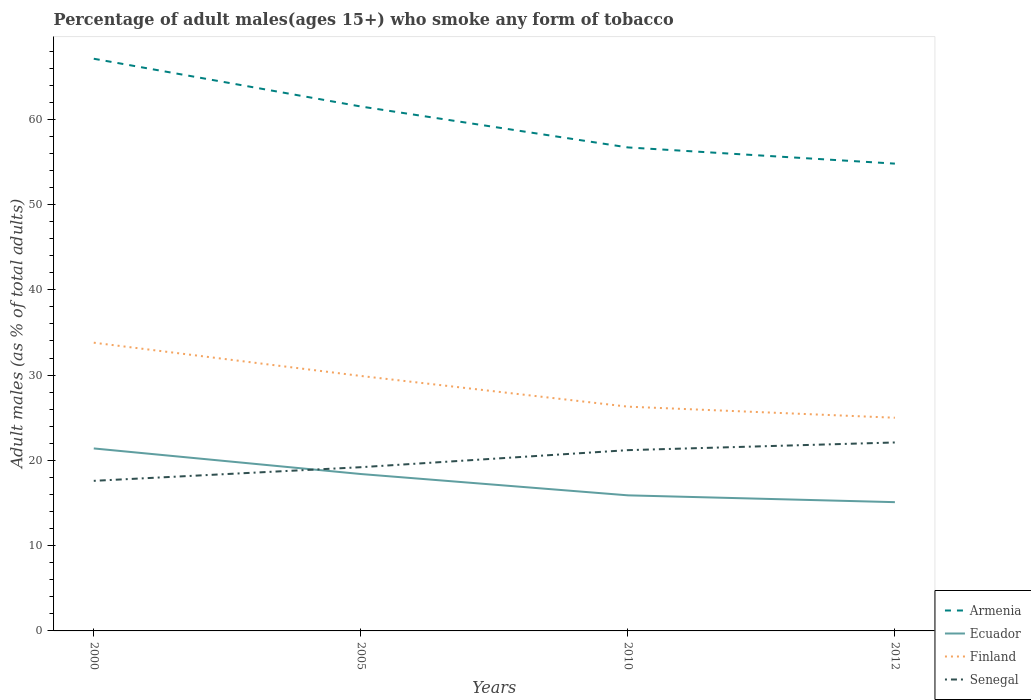How many different coloured lines are there?
Offer a very short reply. 4. Is the number of lines equal to the number of legend labels?
Provide a succinct answer. Yes. Across all years, what is the maximum percentage of adult males who smoke in Armenia?
Your answer should be compact. 54.8. In which year was the percentage of adult males who smoke in Senegal maximum?
Your answer should be compact. 2000. What is the total percentage of adult males who smoke in Finland in the graph?
Your answer should be very brief. 3.9. What is the difference between the highest and the second highest percentage of adult males who smoke in Senegal?
Keep it short and to the point. 4.5. What is the difference between the highest and the lowest percentage of adult males who smoke in Ecuador?
Give a very brief answer. 2. What is the difference between two consecutive major ticks on the Y-axis?
Provide a short and direct response. 10. Does the graph contain grids?
Make the answer very short. No. What is the title of the graph?
Your answer should be very brief. Percentage of adult males(ages 15+) who smoke any form of tobacco. Does "Yemen, Rep." appear as one of the legend labels in the graph?
Provide a short and direct response. No. What is the label or title of the Y-axis?
Offer a terse response. Adult males (as % of total adults). What is the Adult males (as % of total adults) in Armenia in 2000?
Your answer should be compact. 67.1. What is the Adult males (as % of total adults) in Ecuador in 2000?
Provide a succinct answer. 21.4. What is the Adult males (as % of total adults) of Finland in 2000?
Give a very brief answer. 33.8. What is the Adult males (as % of total adults) in Armenia in 2005?
Give a very brief answer. 61.5. What is the Adult males (as % of total adults) of Ecuador in 2005?
Your answer should be very brief. 18.4. What is the Adult males (as % of total adults) of Finland in 2005?
Offer a terse response. 29.9. What is the Adult males (as % of total adults) in Armenia in 2010?
Ensure brevity in your answer.  56.7. What is the Adult males (as % of total adults) in Finland in 2010?
Keep it short and to the point. 26.3. What is the Adult males (as % of total adults) of Senegal in 2010?
Keep it short and to the point. 21.2. What is the Adult males (as % of total adults) of Armenia in 2012?
Your response must be concise. 54.8. What is the Adult males (as % of total adults) of Ecuador in 2012?
Give a very brief answer. 15.1. What is the Adult males (as % of total adults) of Finland in 2012?
Provide a succinct answer. 25. What is the Adult males (as % of total adults) in Senegal in 2012?
Provide a succinct answer. 22.1. Across all years, what is the maximum Adult males (as % of total adults) of Armenia?
Offer a very short reply. 67.1. Across all years, what is the maximum Adult males (as % of total adults) of Ecuador?
Ensure brevity in your answer.  21.4. Across all years, what is the maximum Adult males (as % of total adults) of Finland?
Give a very brief answer. 33.8. Across all years, what is the maximum Adult males (as % of total adults) of Senegal?
Provide a short and direct response. 22.1. Across all years, what is the minimum Adult males (as % of total adults) in Armenia?
Make the answer very short. 54.8. Across all years, what is the minimum Adult males (as % of total adults) in Ecuador?
Provide a succinct answer. 15.1. Across all years, what is the minimum Adult males (as % of total adults) of Finland?
Ensure brevity in your answer.  25. What is the total Adult males (as % of total adults) of Armenia in the graph?
Provide a short and direct response. 240.1. What is the total Adult males (as % of total adults) in Ecuador in the graph?
Give a very brief answer. 70.8. What is the total Adult males (as % of total adults) of Finland in the graph?
Your answer should be very brief. 115. What is the total Adult males (as % of total adults) of Senegal in the graph?
Provide a short and direct response. 80.1. What is the difference between the Adult males (as % of total adults) in Armenia in 2000 and that in 2005?
Make the answer very short. 5.6. What is the difference between the Adult males (as % of total adults) in Ecuador in 2000 and that in 2005?
Your answer should be very brief. 3. What is the difference between the Adult males (as % of total adults) in Senegal in 2000 and that in 2005?
Keep it short and to the point. -1.6. What is the difference between the Adult males (as % of total adults) in Armenia in 2000 and that in 2010?
Offer a terse response. 10.4. What is the difference between the Adult males (as % of total adults) of Ecuador in 2000 and that in 2010?
Keep it short and to the point. 5.5. What is the difference between the Adult males (as % of total adults) of Finland in 2000 and that in 2010?
Provide a short and direct response. 7.5. What is the difference between the Adult males (as % of total adults) in Senegal in 2000 and that in 2010?
Ensure brevity in your answer.  -3.6. What is the difference between the Adult males (as % of total adults) of Armenia in 2000 and that in 2012?
Your response must be concise. 12.3. What is the difference between the Adult males (as % of total adults) of Ecuador in 2000 and that in 2012?
Offer a very short reply. 6.3. What is the difference between the Adult males (as % of total adults) in Finland in 2000 and that in 2012?
Make the answer very short. 8.8. What is the difference between the Adult males (as % of total adults) of Senegal in 2005 and that in 2010?
Provide a short and direct response. -2. What is the difference between the Adult males (as % of total adults) of Armenia in 2005 and that in 2012?
Make the answer very short. 6.7. What is the difference between the Adult males (as % of total adults) in Ecuador in 2005 and that in 2012?
Offer a very short reply. 3.3. What is the difference between the Adult males (as % of total adults) in Finland in 2005 and that in 2012?
Provide a succinct answer. 4.9. What is the difference between the Adult males (as % of total adults) in Senegal in 2010 and that in 2012?
Keep it short and to the point. -0.9. What is the difference between the Adult males (as % of total adults) in Armenia in 2000 and the Adult males (as % of total adults) in Ecuador in 2005?
Your answer should be very brief. 48.7. What is the difference between the Adult males (as % of total adults) of Armenia in 2000 and the Adult males (as % of total adults) of Finland in 2005?
Give a very brief answer. 37.2. What is the difference between the Adult males (as % of total adults) of Armenia in 2000 and the Adult males (as % of total adults) of Senegal in 2005?
Make the answer very short. 47.9. What is the difference between the Adult males (as % of total adults) of Ecuador in 2000 and the Adult males (as % of total adults) of Senegal in 2005?
Your answer should be very brief. 2.2. What is the difference between the Adult males (as % of total adults) in Armenia in 2000 and the Adult males (as % of total adults) in Ecuador in 2010?
Your answer should be compact. 51.2. What is the difference between the Adult males (as % of total adults) in Armenia in 2000 and the Adult males (as % of total adults) in Finland in 2010?
Your response must be concise. 40.8. What is the difference between the Adult males (as % of total adults) in Armenia in 2000 and the Adult males (as % of total adults) in Senegal in 2010?
Provide a succinct answer. 45.9. What is the difference between the Adult males (as % of total adults) of Ecuador in 2000 and the Adult males (as % of total adults) of Finland in 2010?
Provide a succinct answer. -4.9. What is the difference between the Adult males (as % of total adults) in Ecuador in 2000 and the Adult males (as % of total adults) in Senegal in 2010?
Your response must be concise. 0.2. What is the difference between the Adult males (as % of total adults) in Finland in 2000 and the Adult males (as % of total adults) in Senegal in 2010?
Ensure brevity in your answer.  12.6. What is the difference between the Adult males (as % of total adults) of Armenia in 2000 and the Adult males (as % of total adults) of Finland in 2012?
Offer a terse response. 42.1. What is the difference between the Adult males (as % of total adults) of Armenia in 2005 and the Adult males (as % of total adults) of Ecuador in 2010?
Ensure brevity in your answer.  45.6. What is the difference between the Adult males (as % of total adults) of Armenia in 2005 and the Adult males (as % of total adults) of Finland in 2010?
Ensure brevity in your answer.  35.2. What is the difference between the Adult males (as % of total adults) in Armenia in 2005 and the Adult males (as % of total adults) in Senegal in 2010?
Your response must be concise. 40.3. What is the difference between the Adult males (as % of total adults) in Finland in 2005 and the Adult males (as % of total adults) in Senegal in 2010?
Your answer should be compact. 8.7. What is the difference between the Adult males (as % of total adults) of Armenia in 2005 and the Adult males (as % of total adults) of Ecuador in 2012?
Ensure brevity in your answer.  46.4. What is the difference between the Adult males (as % of total adults) of Armenia in 2005 and the Adult males (as % of total adults) of Finland in 2012?
Ensure brevity in your answer.  36.5. What is the difference between the Adult males (as % of total adults) of Armenia in 2005 and the Adult males (as % of total adults) of Senegal in 2012?
Offer a very short reply. 39.4. What is the difference between the Adult males (as % of total adults) in Ecuador in 2005 and the Adult males (as % of total adults) in Finland in 2012?
Your response must be concise. -6.6. What is the difference between the Adult males (as % of total adults) in Armenia in 2010 and the Adult males (as % of total adults) in Ecuador in 2012?
Your response must be concise. 41.6. What is the difference between the Adult males (as % of total adults) of Armenia in 2010 and the Adult males (as % of total adults) of Finland in 2012?
Offer a very short reply. 31.7. What is the difference between the Adult males (as % of total adults) in Armenia in 2010 and the Adult males (as % of total adults) in Senegal in 2012?
Your response must be concise. 34.6. What is the difference between the Adult males (as % of total adults) of Ecuador in 2010 and the Adult males (as % of total adults) of Finland in 2012?
Ensure brevity in your answer.  -9.1. What is the difference between the Adult males (as % of total adults) in Ecuador in 2010 and the Adult males (as % of total adults) in Senegal in 2012?
Give a very brief answer. -6.2. What is the difference between the Adult males (as % of total adults) of Finland in 2010 and the Adult males (as % of total adults) of Senegal in 2012?
Provide a short and direct response. 4.2. What is the average Adult males (as % of total adults) of Armenia per year?
Provide a succinct answer. 60.02. What is the average Adult males (as % of total adults) of Finland per year?
Ensure brevity in your answer.  28.75. What is the average Adult males (as % of total adults) in Senegal per year?
Make the answer very short. 20.02. In the year 2000, what is the difference between the Adult males (as % of total adults) of Armenia and Adult males (as % of total adults) of Ecuador?
Offer a very short reply. 45.7. In the year 2000, what is the difference between the Adult males (as % of total adults) in Armenia and Adult males (as % of total adults) in Finland?
Keep it short and to the point. 33.3. In the year 2000, what is the difference between the Adult males (as % of total adults) in Armenia and Adult males (as % of total adults) in Senegal?
Keep it short and to the point. 49.5. In the year 2000, what is the difference between the Adult males (as % of total adults) of Ecuador and Adult males (as % of total adults) of Senegal?
Offer a very short reply. 3.8. In the year 2000, what is the difference between the Adult males (as % of total adults) of Finland and Adult males (as % of total adults) of Senegal?
Provide a succinct answer. 16.2. In the year 2005, what is the difference between the Adult males (as % of total adults) of Armenia and Adult males (as % of total adults) of Ecuador?
Give a very brief answer. 43.1. In the year 2005, what is the difference between the Adult males (as % of total adults) in Armenia and Adult males (as % of total adults) in Finland?
Provide a short and direct response. 31.6. In the year 2005, what is the difference between the Adult males (as % of total adults) of Armenia and Adult males (as % of total adults) of Senegal?
Make the answer very short. 42.3. In the year 2005, what is the difference between the Adult males (as % of total adults) in Ecuador and Adult males (as % of total adults) in Senegal?
Your answer should be compact. -0.8. In the year 2005, what is the difference between the Adult males (as % of total adults) in Finland and Adult males (as % of total adults) in Senegal?
Keep it short and to the point. 10.7. In the year 2010, what is the difference between the Adult males (as % of total adults) in Armenia and Adult males (as % of total adults) in Ecuador?
Your answer should be very brief. 40.8. In the year 2010, what is the difference between the Adult males (as % of total adults) in Armenia and Adult males (as % of total adults) in Finland?
Provide a short and direct response. 30.4. In the year 2010, what is the difference between the Adult males (as % of total adults) of Armenia and Adult males (as % of total adults) of Senegal?
Offer a very short reply. 35.5. In the year 2010, what is the difference between the Adult males (as % of total adults) in Ecuador and Adult males (as % of total adults) in Senegal?
Your answer should be very brief. -5.3. In the year 2010, what is the difference between the Adult males (as % of total adults) in Finland and Adult males (as % of total adults) in Senegal?
Ensure brevity in your answer.  5.1. In the year 2012, what is the difference between the Adult males (as % of total adults) in Armenia and Adult males (as % of total adults) in Ecuador?
Your response must be concise. 39.7. In the year 2012, what is the difference between the Adult males (as % of total adults) in Armenia and Adult males (as % of total adults) in Finland?
Offer a very short reply. 29.8. In the year 2012, what is the difference between the Adult males (as % of total adults) in Armenia and Adult males (as % of total adults) in Senegal?
Provide a succinct answer. 32.7. In the year 2012, what is the difference between the Adult males (as % of total adults) of Ecuador and Adult males (as % of total adults) of Finland?
Provide a succinct answer. -9.9. In the year 2012, what is the difference between the Adult males (as % of total adults) of Finland and Adult males (as % of total adults) of Senegal?
Your response must be concise. 2.9. What is the ratio of the Adult males (as % of total adults) in Armenia in 2000 to that in 2005?
Your answer should be very brief. 1.09. What is the ratio of the Adult males (as % of total adults) of Ecuador in 2000 to that in 2005?
Keep it short and to the point. 1.16. What is the ratio of the Adult males (as % of total adults) in Finland in 2000 to that in 2005?
Your response must be concise. 1.13. What is the ratio of the Adult males (as % of total adults) in Senegal in 2000 to that in 2005?
Your answer should be very brief. 0.92. What is the ratio of the Adult males (as % of total adults) in Armenia in 2000 to that in 2010?
Give a very brief answer. 1.18. What is the ratio of the Adult males (as % of total adults) of Ecuador in 2000 to that in 2010?
Your answer should be compact. 1.35. What is the ratio of the Adult males (as % of total adults) in Finland in 2000 to that in 2010?
Give a very brief answer. 1.29. What is the ratio of the Adult males (as % of total adults) of Senegal in 2000 to that in 2010?
Keep it short and to the point. 0.83. What is the ratio of the Adult males (as % of total adults) in Armenia in 2000 to that in 2012?
Offer a very short reply. 1.22. What is the ratio of the Adult males (as % of total adults) of Ecuador in 2000 to that in 2012?
Offer a very short reply. 1.42. What is the ratio of the Adult males (as % of total adults) in Finland in 2000 to that in 2012?
Offer a very short reply. 1.35. What is the ratio of the Adult males (as % of total adults) in Senegal in 2000 to that in 2012?
Make the answer very short. 0.8. What is the ratio of the Adult males (as % of total adults) in Armenia in 2005 to that in 2010?
Make the answer very short. 1.08. What is the ratio of the Adult males (as % of total adults) in Ecuador in 2005 to that in 2010?
Give a very brief answer. 1.16. What is the ratio of the Adult males (as % of total adults) in Finland in 2005 to that in 2010?
Ensure brevity in your answer.  1.14. What is the ratio of the Adult males (as % of total adults) of Senegal in 2005 to that in 2010?
Your answer should be very brief. 0.91. What is the ratio of the Adult males (as % of total adults) of Armenia in 2005 to that in 2012?
Your answer should be very brief. 1.12. What is the ratio of the Adult males (as % of total adults) in Ecuador in 2005 to that in 2012?
Give a very brief answer. 1.22. What is the ratio of the Adult males (as % of total adults) in Finland in 2005 to that in 2012?
Give a very brief answer. 1.2. What is the ratio of the Adult males (as % of total adults) of Senegal in 2005 to that in 2012?
Ensure brevity in your answer.  0.87. What is the ratio of the Adult males (as % of total adults) of Armenia in 2010 to that in 2012?
Offer a terse response. 1.03. What is the ratio of the Adult males (as % of total adults) of Ecuador in 2010 to that in 2012?
Keep it short and to the point. 1.05. What is the ratio of the Adult males (as % of total adults) in Finland in 2010 to that in 2012?
Provide a short and direct response. 1.05. What is the ratio of the Adult males (as % of total adults) of Senegal in 2010 to that in 2012?
Provide a short and direct response. 0.96. What is the difference between the highest and the second highest Adult males (as % of total adults) in Armenia?
Provide a short and direct response. 5.6. What is the difference between the highest and the second highest Adult males (as % of total adults) of Finland?
Offer a very short reply. 3.9. What is the difference between the highest and the second highest Adult males (as % of total adults) of Senegal?
Offer a very short reply. 0.9. What is the difference between the highest and the lowest Adult males (as % of total adults) in Senegal?
Your answer should be compact. 4.5. 